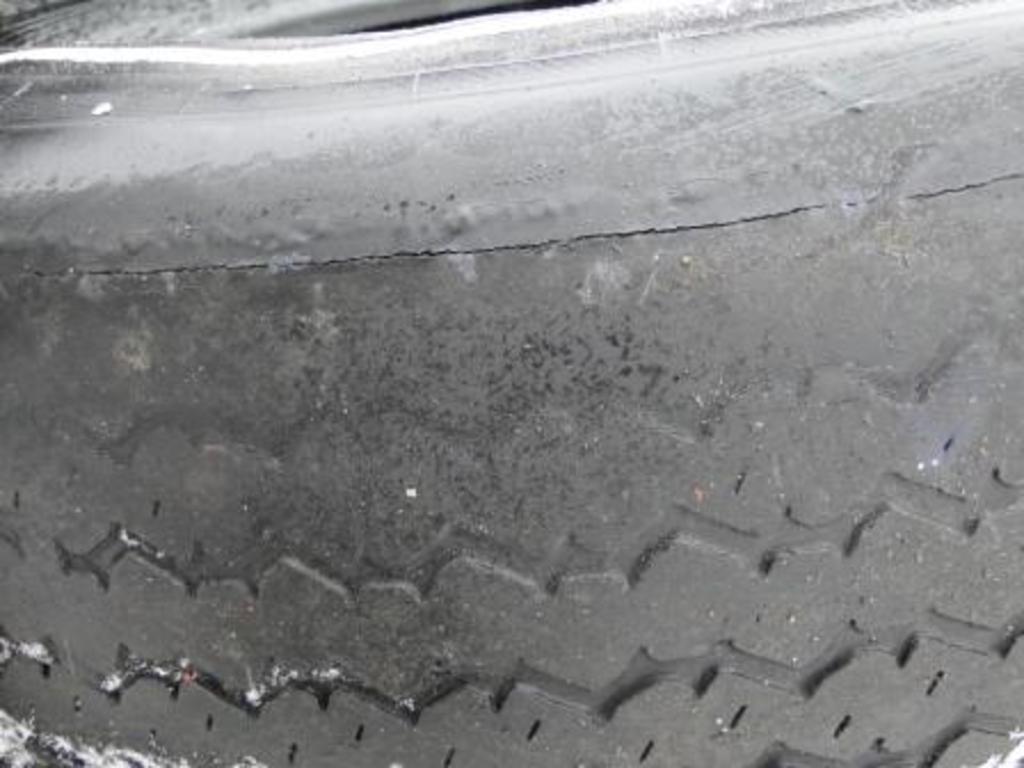In one or two sentences, can you explain what this image depicts? In this image we can see there is a tire. 